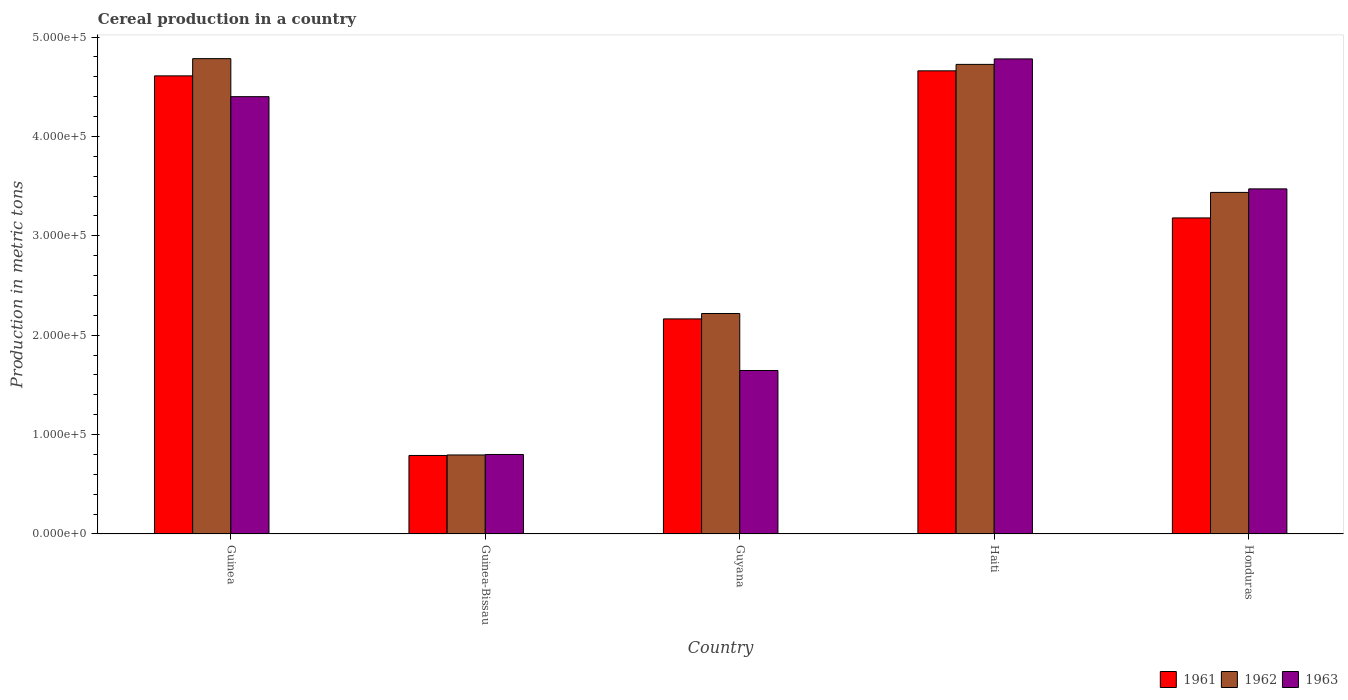What is the label of the 4th group of bars from the left?
Your answer should be very brief. Haiti. What is the total cereal production in 1961 in Haiti?
Offer a terse response. 4.66e+05. Across all countries, what is the maximum total cereal production in 1963?
Your answer should be compact. 4.78e+05. Across all countries, what is the minimum total cereal production in 1962?
Offer a terse response. 7.95e+04. In which country was the total cereal production in 1962 maximum?
Make the answer very short. Guinea. In which country was the total cereal production in 1963 minimum?
Provide a short and direct response. Guinea-Bissau. What is the total total cereal production in 1961 in the graph?
Ensure brevity in your answer.  1.54e+06. What is the difference between the total cereal production in 1963 in Guinea and that in Guyana?
Your answer should be compact. 2.76e+05. What is the difference between the total cereal production in 1961 in Guinea and the total cereal production in 1963 in Haiti?
Offer a terse response. -1.71e+04. What is the average total cereal production in 1962 per country?
Keep it short and to the point. 3.19e+05. What is the difference between the total cereal production of/in 1962 and total cereal production of/in 1961 in Haiti?
Offer a very short reply. 6500. What is the ratio of the total cereal production in 1962 in Guinea to that in Haiti?
Keep it short and to the point. 1.01. Is the total cereal production in 1963 in Guinea-Bissau less than that in Guyana?
Your answer should be compact. Yes. What is the difference between the highest and the second highest total cereal production in 1962?
Ensure brevity in your answer.  -1.29e+05. What is the difference between the highest and the lowest total cereal production in 1961?
Keep it short and to the point. 3.87e+05. What does the 3rd bar from the left in Honduras represents?
Offer a terse response. 1963. What does the 1st bar from the right in Guinea-Bissau represents?
Your answer should be compact. 1963. How many countries are there in the graph?
Provide a short and direct response. 5. What is the difference between two consecutive major ticks on the Y-axis?
Give a very brief answer. 1.00e+05. Are the values on the major ticks of Y-axis written in scientific E-notation?
Your answer should be very brief. Yes. Does the graph contain any zero values?
Give a very brief answer. No. What is the title of the graph?
Keep it short and to the point. Cereal production in a country. What is the label or title of the X-axis?
Your answer should be compact. Country. What is the label or title of the Y-axis?
Provide a short and direct response. Production in metric tons. What is the Production in metric tons of 1961 in Guinea?
Your answer should be very brief. 4.61e+05. What is the Production in metric tons in 1962 in Guinea?
Offer a very short reply. 4.78e+05. What is the Production in metric tons of 1963 in Guinea?
Offer a terse response. 4.40e+05. What is the Production in metric tons of 1961 in Guinea-Bissau?
Keep it short and to the point. 7.90e+04. What is the Production in metric tons of 1962 in Guinea-Bissau?
Offer a terse response. 7.95e+04. What is the Production in metric tons in 1961 in Guyana?
Offer a terse response. 2.16e+05. What is the Production in metric tons of 1962 in Guyana?
Provide a succinct answer. 2.22e+05. What is the Production in metric tons of 1963 in Guyana?
Your answer should be compact. 1.64e+05. What is the Production in metric tons of 1961 in Haiti?
Keep it short and to the point. 4.66e+05. What is the Production in metric tons of 1962 in Haiti?
Keep it short and to the point. 4.72e+05. What is the Production in metric tons in 1963 in Haiti?
Your answer should be compact. 4.78e+05. What is the Production in metric tons of 1961 in Honduras?
Keep it short and to the point. 3.18e+05. What is the Production in metric tons of 1962 in Honduras?
Offer a terse response. 3.44e+05. What is the Production in metric tons in 1963 in Honduras?
Offer a very short reply. 3.47e+05. Across all countries, what is the maximum Production in metric tons of 1961?
Provide a short and direct response. 4.66e+05. Across all countries, what is the maximum Production in metric tons in 1962?
Offer a very short reply. 4.78e+05. Across all countries, what is the maximum Production in metric tons of 1963?
Give a very brief answer. 4.78e+05. Across all countries, what is the minimum Production in metric tons in 1961?
Make the answer very short. 7.90e+04. Across all countries, what is the minimum Production in metric tons of 1962?
Give a very brief answer. 7.95e+04. Across all countries, what is the minimum Production in metric tons of 1963?
Offer a terse response. 8.00e+04. What is the total Production in metric tons of 1961 in the graph?
Your answer should be very brief. 1.54e+06. What is the total Production in metric tons in 1962 in the graph?
Keep it short and to the point. 1.60e+06. What is the total Production in metric tons of 1963 in the graph?
Your answer should be compact. 1.51e+06. What is the difference between the Production in metric tons in 1961 in Guinea and that in Guinea-Bissau?
Offer a terse response. 3.82e+05. What is the difference between the Production in metric tons in 1962 in Guinea and that in Guinea-Bissau?
Ensure brevity in your answer.  3.99e+05. What is the difference between the Production in metric tons in 1963 in Guinea and that in Guinea-Bissau?
Make the answer very short. 3.60e+05. What is the difference between the Production in metric tons in 1961 in Guinea and that in Guyana?
Make the answer very short. 2.45e+05. What is the difference between the Production in metric tons in 1962 in Guinea and that in Guyana?
Offer a very short reply. 2.56e+05. What is the difference between the Production in metric tons in 1963 in Guinea and that in Guyana?
Your answer should be very brief. 2.76e+05. What is the difference between the Production in metric tons of 1961 in Guinea and that in Haiti?
Offer a very short reply. -5060. What is the difference between the Production in metric tons in 1962 in Guinea and that in Haiti?
Offer a terse response. 5770. What is the difference between the Production in metric tons in 1963 in Guinea and that in Haiti?
Keep it short and to the point. -3.80e+04. What is the difference between the Production in metric tons in 1961 in Guinea and that in Honduras?
Offer a terse response. 1.43e+05. What is the difference between the Production in metric tons in 1962 in Guinea and that in Honduras?
Give a very brief answer. 1.35e+05. What is the difference between the Production in metric tons in 1963 in Guinea and that in Honduras?
Your answer should be very brief. 9.28e+04. What is the difference between the Production in metric tons of 1961 in Guinea-Bissau and that in Guyana?
Make the answer very short. -1.37e+05. What is the difference between the Production in metric tons of 1962 in Guinea-Bissau and that in Guyana?
Offer a very short reply. -1.42e+05. What is the difference between the Production in metric tons in 1963 in Guinea-Bissau and that in Guyana?
Offer a very short reply. -8.45e+04. What is the difference between the Production in metric tons of 1961 in Guinea-Bissau and that in Haiti?
Make the answer very short. -3.87e+05. What is the difference between the Production in metric tons of 1962 in Guinea-Bissau and that in Haiti?
Offer a very short reply. -3.93e+05. What is the difference between the Production in metric tons in 1963 in Guinea-Bissau and that in Haiti?
Offer a terse response. -3.98e+05. What is the difference between the Production in metric tons in 1961 in Guinea-Bissau and that in Honduras?
Give a very brief answer. -2.39e+05. What is the difference between the Production in metric tons in 1962 in Guinea-Bissau and that in Honduras?
Provide a short and direct response. -2.64e+05. What is the difference between the Production in metric tons of 1963 in Guinea-Bissau and that in Honduras?
Your answer should be very brief. -2.67e+05. What is the difference between the Production in metric tons in 1961 in Guyana and that in Haiti?
Your answer should be compact. -2.50e+05. What is the difference between the Production in metric tons in 1962 in Guyana and that in Haiti?
Provide a short and direct response. -2.51e+05. What is the difference between the Production in metric tons of 1963 in Guyana and that in Haiti?
Make the answer very short. -3.14e+05. What is the difference between the Production in metric tons of 1961 in Guyana and that in Honduras?
Ensure brevity in your answer.  -1.02e+05. What is the difference between the Production in metric tons of 1962 in Guyana and that in Honduras?
Provide a succinct answer. -1.22e+05. What is the difference between the Production in metric tons of 1963 in Guyana and that in Honduras?
Your answer should be very brief. -1.83e+05. What is the difference between the Production in metric tons of 1961 in Haiti and that in Honduras?
Your answer should be very brief. 1.48e+05. What is the difference between the Production in metric tons of 1962 in Haiti and that in Honduras?
Make the answer very short. 1.29e+05. What is the difference between the Production in metric tons in 1963 in Haiti and that in Honduras?
Provide a succinct answer. 1.31e+05. What is the difference between the Production in metric tons in 1961 in Guinea and the Production in metric tons in 1962 in Guinea-Bissau?
Ensure brevity in your answer.  3.81e+05. What is the difference between the Production in metric tons in 1961 in Guinea and the Production in metric tons in 1963 in Guinea-Bissau?
Your response must be concise. 3.81e+05. What is the difference between the Production in metric tons in 1962 in Guinea and the Production in metric tons in 1963 in Guinea-Bissau?
Provide a succinct answer. 3.98e+05. What is the difference between the Production in metric tons in 1961 in Guinea and the Production in metric tons in 1962 in Guyana?
Make the answer very short. 2.39e+05. What is the difference between the Production in metric tons in 1961 in Guinea and the Production in metric tons in 1963 in Guyana?
Offer a very short reply. 2.96e+05. What is the difference between the Production in metric tons of 1962 in Guinea and the Production in metric tons of 1963 in Guyana?
Make the answer very short. 3.14e+05. What is the difference between the Production in metric tons in 1961 in Guinea and the Production in metric tons in 1962 in Haiti?
Make the answer very short. -1.16e+04. What is the difference between the Production in metric tons in 1961 in Guinea and the Production in metric tons in 1963 in Haiti?
Keep it short and to the point. -1.71e+04. What is the difference between the Production in metric tons in 1962 in Guinea and the Production in metric tons in 1963 in Haiti?
Offer a terse response. 270. What is the difference between the Production in metric tons of 1961 in Guinea and the Production in metric tons of 1962 in Honduras?
Your answer should be compact. 1.17e+05. What is the difference between the Production in metric tons of 1961 in Guinea and the Production in metric tons of 1963 in Honduras?
Give a very brief answer. 1.14e+05. What is the difference between the Production in metric tons in 1962 in Guinea and the Production in metric tons in 1963 in Honduras?
Make the answer very short. 1.31e+05. What is the difference between the Production in metric tons of 1961 in Guinea-Bissau and the Production in metric tons of 1962 in Guyana?
Your answer should be compact. -1.43e+05. What is the difference between the Production in metric tons of 1961 in Guinea-Bissau and the Production in metric tons of 1963 in Guyana?
Offer a terse response. -8.55e+04. What is the difference between the Production in metric tons in 1962 in Guinea-Bissau and the Production in metric tons in 1963 in Guyana?
Offer a terse response. -8.50e+04. What is the difference between the Production in metric tons in 1961 in Guinea-Bissau and the Production in metric tons in 1962 in Haiti?
Make the answer very short. -3.94e+05. What is the difference between the Production in metric tons of 1961 in Guinea-Bissau and the Production in metric tons of 1963 in Haiti?
Offer a very short reply. -3.99e+05. What is the difference between the Production in metric tons in 1962 in Guinea-Bissau and the Production in metric tons in 1963 in Haiti?
Give a very brief answer. -3.98e+05. What is the difference between the Production in metric tons of 1961 in Guinea-Bissau and the Production in metric tons of 1962 in Honduras?
Provide a short and direct response. -2.65e+05. What is the difference between the Production in metric tons in 1961 in Guinea-Bissau and the Production in metric tons in 1963 in Honduras?
Keep it short and to the point. -2.68e+05. What is the difference between the Production in metric tons in 1962 in Guinea-Bissau and the Production in metric tons in 1963 in Honduras?
Give a very brief answer. -2.68e+05. What is the difference between the Production in metric tons in 1961 in Guyana and the Production in metric tons in 1962 in Haiti?
Provide a short and direct response. -2.56e+05. What is the difference between the Production in metric tons in 1961 in Guyana and the Production in metric tons in 1963 in Haiti?
Ensure brevity in your answer.  -2.62e+05. What is the difference between the Production in metric tons of 1962 in Guyana and the Production in metric tons of 1963 in Haiti?
Your response must be concise. -2.56e+05. What is the difference between the Production in metric tons in 1961 in Guyana and the Production in metric tons in 1962 in Honduras?
Your response must be concise. -1.27e+05. What is the difference between the Production in metric tons of 1961 in Guyana and the Production in metric tons of 1963 in Honduras?
Offer a terse response. -1.31e+05. What is the difference between the Production in metric tons of 1962 in Guyana and the Production in metric tons of 1963 in Honduras?
Keep it short and to the point. -1.25e+05. What is the difference between the Production in metric tons in 1961 in Haiti and the Production in metric tons in 1962 in Honduras?
Give a very brief answer. 1.22e+05. What is the difference between the Production in metric tons of 1961 in Haiti and the Production in metric tons of 1963 in Honduras?
Provide a short and direct response. 1.19e+05. What is the difference between the Production in metric tons in 1962 in Haiti and the Production in metric tons in 1963 in Honduras?
Offer a terse response. 1.25e+05. What is the average Production in metric tons in 1961 per country?
Offer a terse response. 3.08e+05. What is the average Production in metric tons of 1962 per country?
Provide a short and direct response. 3.19e+05. What is the average Production in metric tons of 1963 per country?
Keep it short and to the point. 3.02e+05. What is the difference between the Production in metric tons in 1961 and Production in metric tons in 1962 in Guinea?
Make the answer very short. -1.73e+04. What is the difference between the Production in metric tons of 1961 and Production in metric tons of 1963 in Guinea?
Ensure brevity in your answer.  2.09e+04. What is the difference between the Production in metric tons of 1962 and Production in metric tons of 1963 in Guinea?
Your answer should be compact. 3.83e+04. What is the difference between the Production in metric tons of 1961 and Production in metric tons of 1962 in Guinea-Bissau?
Your answer should be very brief. -500. What is the difference between the Production in metric tons of 1961 and Production in metric tons of 1963 in Guinea-Bissau?
Ensure brevity in your answer.  -1000. What is the difference between the Production in metric tons in 1962 and Production in metric tons in 1963 in Guinea-Bissau?
Keep it short and to the point. -500. What is the difference between the Production in metric tons in 1961 and Production in metric tons in 1962 in Guyana?
Your response must be concise. -5445. What is the difference between the Production in metric tons in 1961 and Production in metric tons in 1963 in Guyana?
Offer a terse response. 5.19e+04. What is the difference between the Production in metric tons in 1962 and Production in metric tons in 1963 in Guyana?
Your answer should be compact. 5.74e+04. What is the difference between the Production in metric tons of 1961 and Production in metric tons of 1962 in Haiti?
Provide a short and direct response. -6500. What is the difference between the Production in metric tons of 1961 and Production in metric tons of 1963 in Haiti?
Ensure brevity in your answer.  -1.20e+04. What is the difference between the Production in metric tons in 1962 and Production in metric tons in 1963 in Haiti?
Keep it short and to the point. -5500. What is the difference between the Production in metric tons in 1961 and Production in metric tons in 1962 in Honduras?
Your response must be concise. -2.57e+04. What is the difference between the Production in metric tons in 1961 and Production in metric tons in 1963 in Honduras?
Your response must be concise. -2.92e+04. What is the difference between the Production in metric tons in 1962 and Production in metric tons in 1963 in Honduras?
Your response must be concise. -3541. What is the ratio of the Production in metric tons in 1961 in Guinea to that in Guinea-Bissau?
Offer a very short reply. 5.83. What is the ratio of the Production in metric tons in 1962 in Guinea to that in Guinea-Bissau?
Offer a very short reply. 6.02. What is the ratio of the Production in metric tons of 1963 in Guinea to that in Guinea-Bissau?
Your response must be concise. 5.5. What is the ratio of the Production in metric tons in 1961 in Guinea to that in Guyana?
Offer a terse response. 2.13. What is the ratio of the Production in metric tons of 1962 in Guinea to that in Guyana?
Give a very brief answer. 2.16. What is the ratio of the Production in metric tons of 1963 in Guinea to that in Guyana?
Your response must be concise. 2.67. What is the ratio of the Production in metric tons of 1962 in Guinea to that in Haiti?
Offer a very short reply. 1.01. What is the ratio of the Production in metric tons in 1963 in Guinea to that in Haiti?
Offer a very short reply. 0.92. What is the ratio of the Production in metric tons of 1961 in Guinea to that in Honduras?
Your answer should be very brief. 1.45. What is the ratio of the Production in metric tons in 1962 in Guinea to that in Honduras?
Make the answer very short. 1.39. What is the ratio of the Production in metric tons in 1963 in Guinea to that in Honduras?
Offer a very short reply. 1.27. What is the ratio of the Production in metric tons of 1961 in Guinea-Bissau to that in Guyana?
Keep it short and to the point. 0.37. What is the ratio of the Production in metric tons of 1962 in Guinea-Bissau to that in Guyana?
Your answer should be compact. 0.36. What is the ratio of the Production in metric tons of 1963 in Guinea-Bissau to that in Guyana?
Ensure brevity in your answer.  0.49. What is the ratio of the Production in metric tons of 1961 in Guinea-Bissau to that in Haiti?
Your response must be concise. 0.17. What is the ratio of the Production in metric tons in 1962 in Guinea-Bissau to that in Haiti?
Offer a very short reply. 0.17. What is the ratio of the Production in metric tons of 1963 in Guinea-Bissau to that in Haiti?
Ensure brevity in your answer.  0.17. What is the ratio of the Production in metric tons in 1961 in Guinea-Bissau to that in Honduras?
Make the answer very short. 0.25. What is the ratio of the Production in metric tons of 1962 in Guinea-Bissau to that in Honduras?
Your response must be concise. 0.23. What is the ratio of the Production in metric tons of 1963 in Guinea-Bissau to that in Honduras?
Your response must be concise. 0.23. What is the ratio of the Production in metric tons in 1961 in Guyana to that in Haiti?
Your answer should be very brief. 0.46. What is the ratio of the Production in metric tons of 1962 in Guyana to that in Haiti?
Offer a very short reply. 0.47. What is the ratio of the Production in metric tons in 1963 in Guyana to that in Haiti?
Make the answer very short. 0.34. What is the ratio of the Production in metric tons in 1961 in Guyana to that in Honduras?
Offer a very short reply. 0.68. What is the ratio of the Production in metric tons in 1962 in Guyana to that in Honduras?
Ensure brevity in your answer.  0.65. What is the ratio of the Production in metric tons of 1963 in Guyana to that in Honduras?
Give a very brief answer. 0.47. What is the ratio of the Production in metric tons in 1961 in Haiti to that in Honduras?
Your answer should be compact. 1.47. What is the ratio of the Production in metric tons of 1962 in Haiti to that in Honduras?
Ensure brevity in your answer.  1.37. What is the ratio of the Production in metric tons of 1963 in Haiti to that in Honduras?
Offer a terse response. 1.38. What is the difference between the highest and the second highest Production in metric tons in 1961?
Give a very brief answer. 5060. What is the difference between the highest and the second highest Production in metric tons in 1962?
Ensure brevity in your answer.  5770. What is the difference between the highest and the second highest Production in metric tons in 1963?
Ensure brevity in your answer.  3.80e+04. What is the difference between the highest and the lowest Production in metric tons of 1961?
Provide a succinct answer. 3.87e+05. What is the difference between the highest and the lowest Production in metric tons of 1962?
Your response must be concise. 3.99e+05. What is the difference between the highest and the lowest Production in metric tons in 1963?
Ensure brevity in your answer.  3.98e+05. 